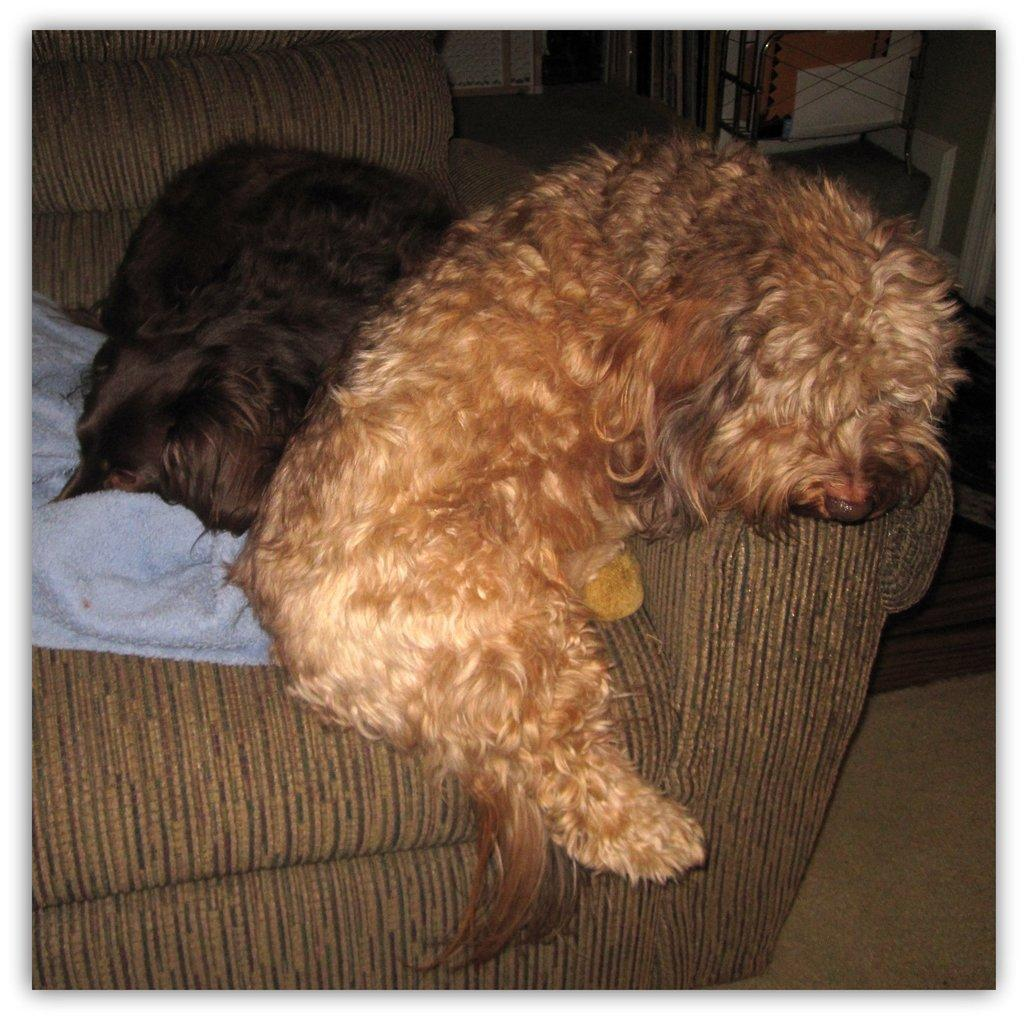How many dogs are in the image? There are two dogs in the image. What are the dogs doing in the image? The dogs are lying on a couch. What is covering the couch in the image? There is a cloth on the couch. What can be seen in the top right corner of the image? There are objects visible in the top right corner of the image. What type of root can be seen growing in the alley in the image? There is no alley or root present in the image; it features two dogs lying on a couch with a cloth covering it. 